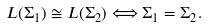<formula> <loc_0><loc_0><loc_500><loc_500>L ( \Sigma _ { 1 } ) \cong L ( \Sigma _ { 2 } ) \Longleftrightarrow \Sigma _ { 1 } = \Sigma _ { 2 } .</formula> 